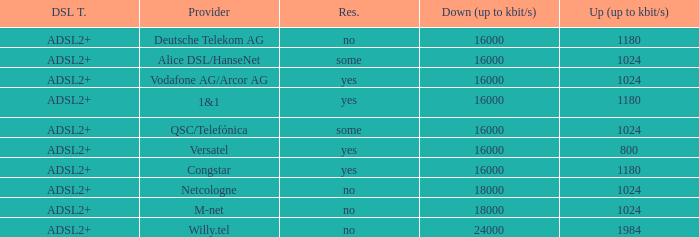What are all the dsl type offered by the M-Net telecom company? ADSL2+. 